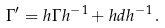<formula> <loc_0><loc_0><loc_500><loc_500>\Gamma ^ { \prime } = h \Gamma h ^ { - 1 } + h d h ^ { - 1 } \, .</formula> 